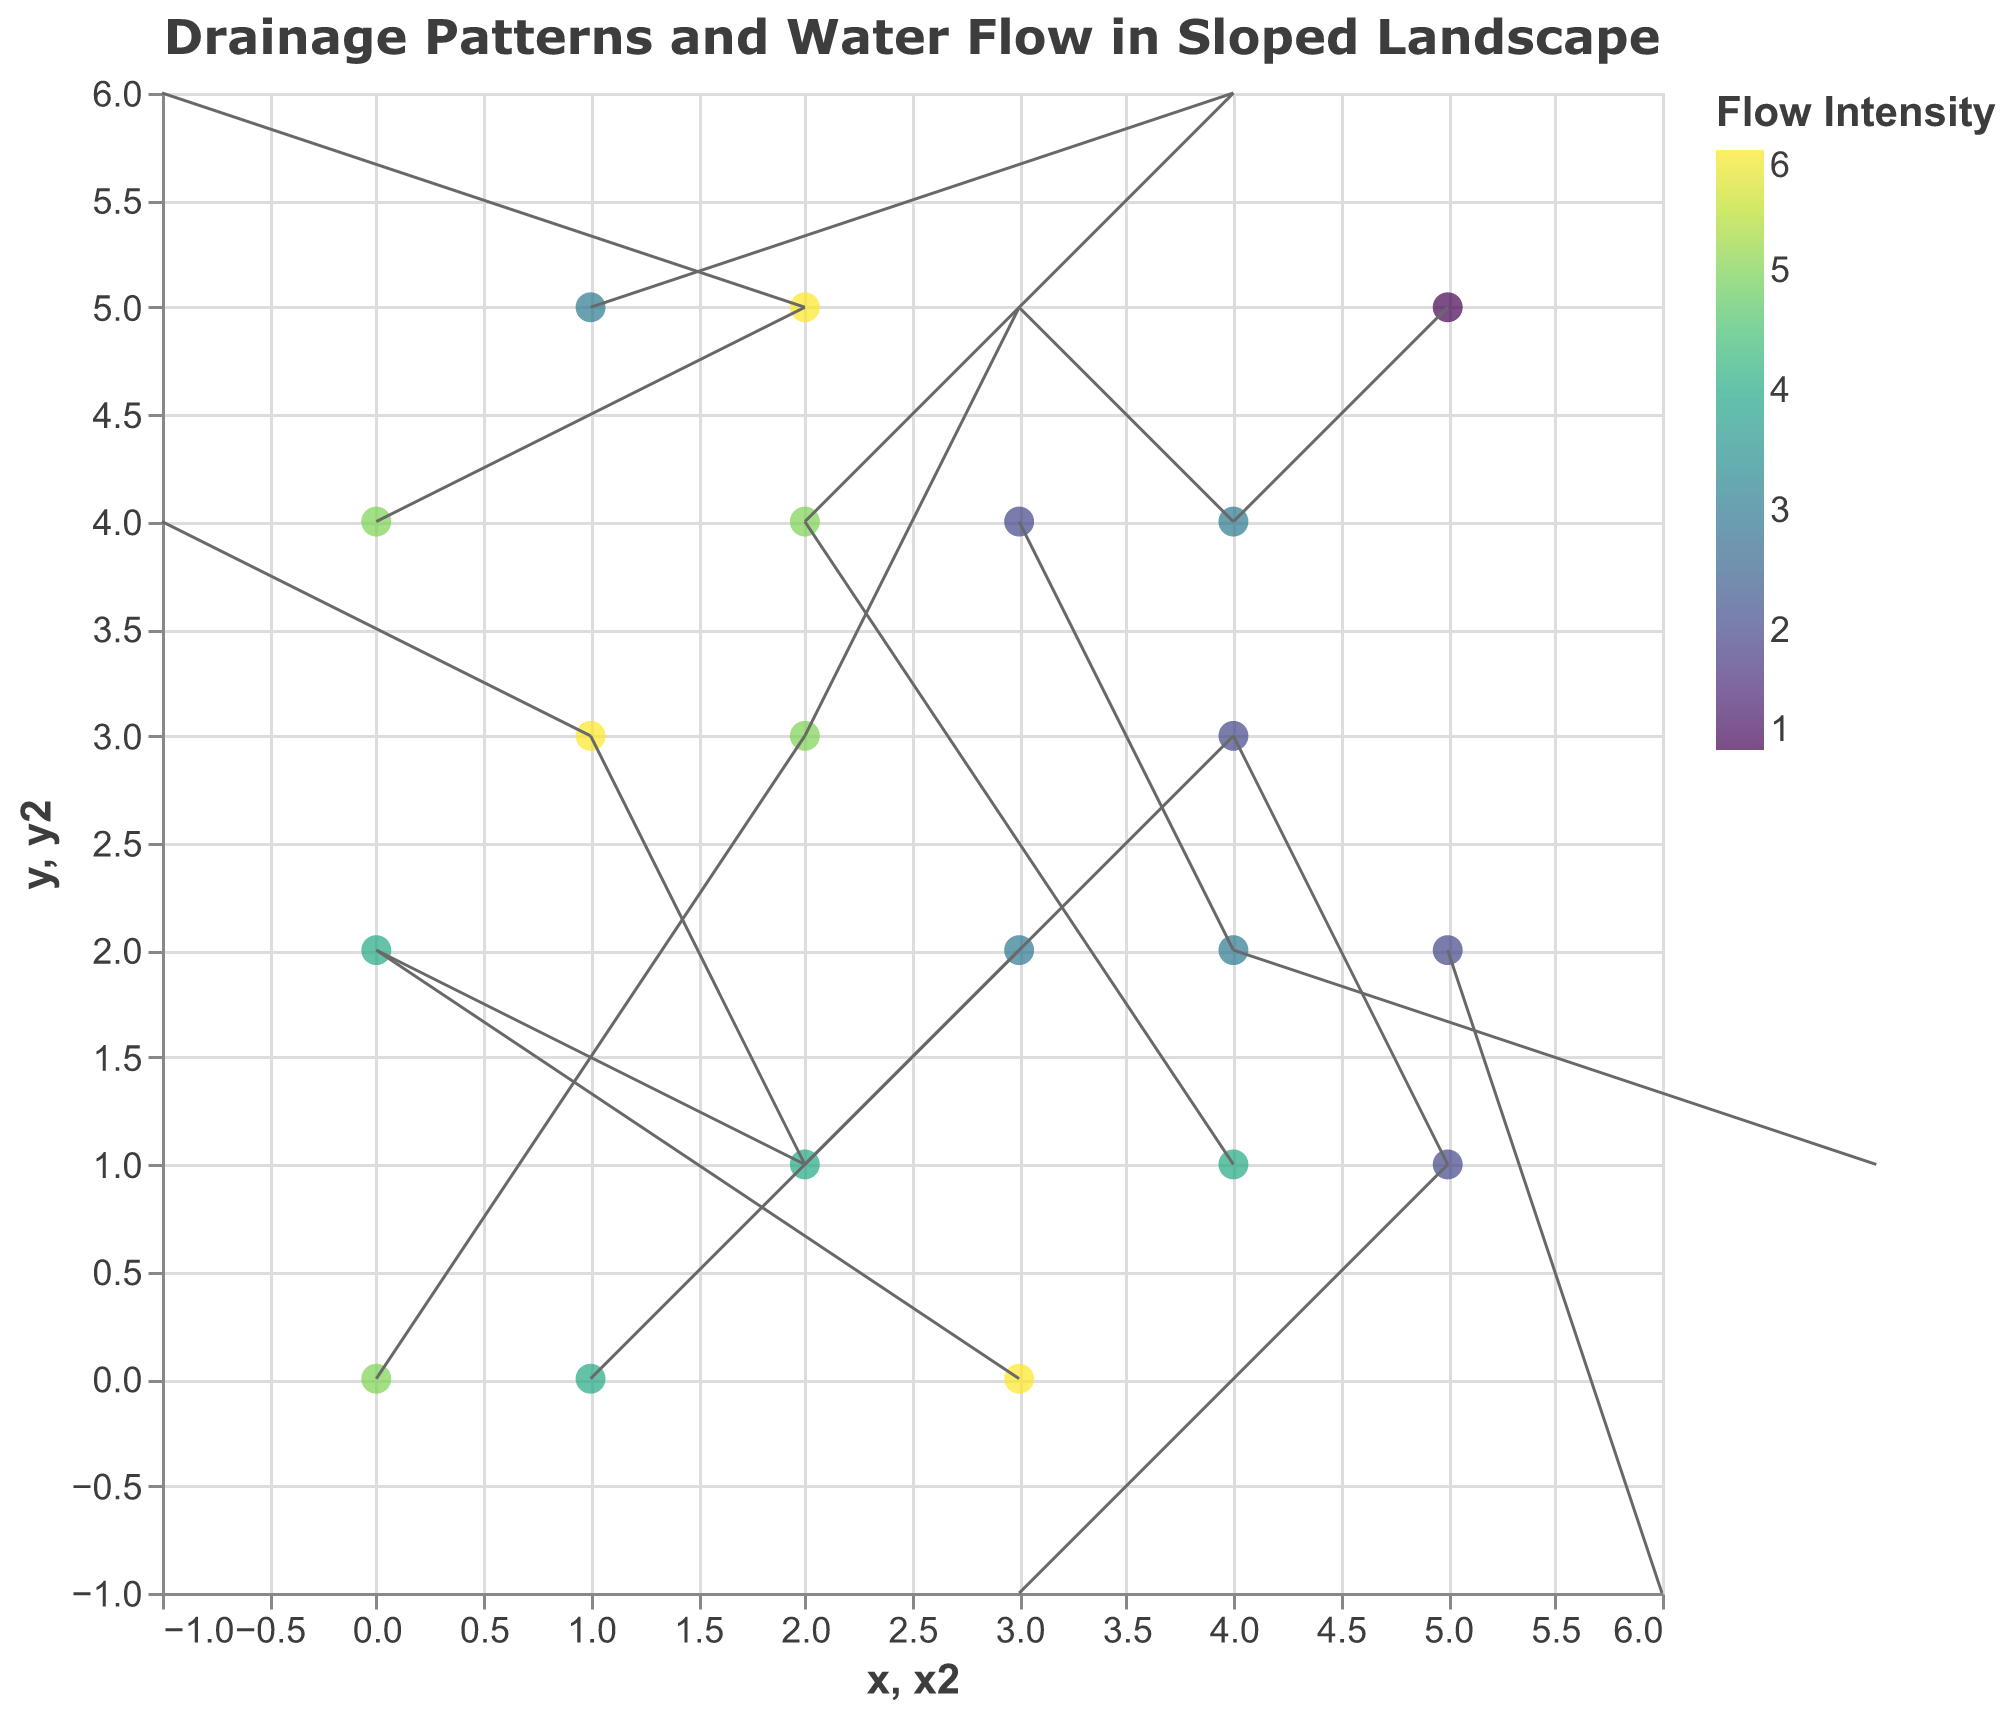How many points on the plot have an intensity of 5? There are multiple points with specific intensity values. Count the number of points that have an intensity value of 5.
Answer: 4 What is the direction of water flow at position (3, 2)? Look at the coordinate (3, 2) and observe the direction of the arrow starting at that position. The 'u' and 'v' values indicate the arrow direction, which is (-1, -1).
Answer: Up-left Which point has the highest flow intensity, and what is its direction? Identify the point(s) with the highest intensity value. The highest intensity is 6, and it occurs at positions (1, 3), (3, 0), and (2, 5). The directions are (-2, 1), (-3, 2), and (-3, 1) respectively.
Answer: (1, 3): Up-left, (3, 0): Down-left, (2, 5): Up-left At which coordinate(s) is the flow directed vertically upwards? Identify points where the arrow points upwards. Upward direction corresponds to 'v' being positive and 'u' being zero or negative. Points with (1, 2), (1, 3), and (4, 3) have appropriate directions.
Answer: (2, 1), (4, 1) Are there any points where water flows directly downwards? Look for points where the 'v' value is negative and 'u' is zero or minimal. Identify coordinates that fit this criterion.
Answer: No points flow directly downwards Compare the flow intensity at (1, 0) and (4, 1). Which is greater? Check the intensity values at (1, 0) and (4, 1), which are 4 and 4, respectively.
Answer: Equal Describe the predominant direction of water flow within the plot. Observe the arrows across the plot and determine the most frequently occurring overall direction. The flow directions vary widely but predominantly move in diagonal directions.
Answer: Varied, predominantly diagonal What is the sum of the intensities of the points along the X-axis (where y=0)? Find all coordinates where y=0 and sum their intensity values: (0, 0), (3, 0), and (1, 0). The intensities are 5, 6, and 4. Thus, the sum is 5+6+4=15.
Answer: 15 